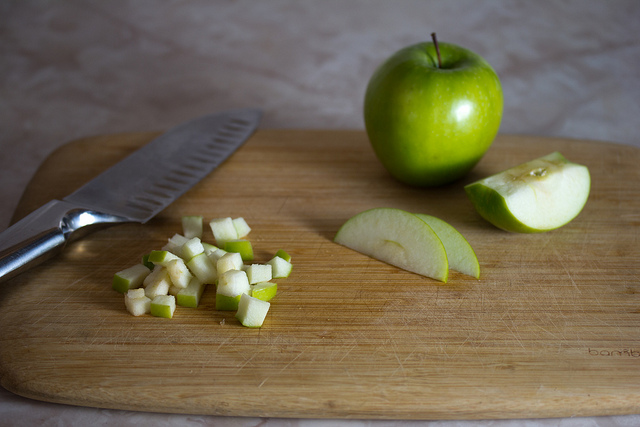Can you think of some dishes that might use diced or sliced apples as an ingredient? Certainly! Diced or sliced apples are versatile in the culinary world, adding delightful flavors and textures to dishes like fresh fruit salads, where they complement other fruits, or in savory mixes such as chicken salads, adding a refreshing crunch. They're also perfect for traditional desserts like apple pies and apple crumbles, where their sweet-tart flavor enhances the dish. Apple slices also find their way into healthier snack options, paired with dips or peanut butter, or add a sweet chew to breakfast oats and cereals. 